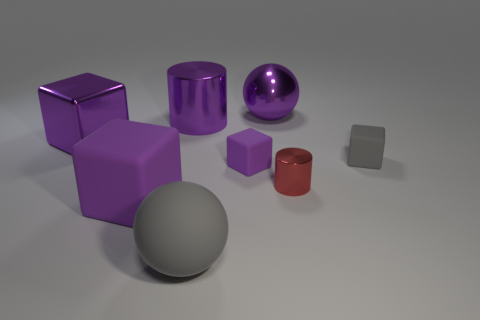Subtract all cyan spheres. How many purple blocks are left? 3 Subtract 1 cubes. How many cubes are left? 3 Add 2 yellow rubber objects. How many objects exist? 10 Subtract all spheres. How many objects are left? 6 Add 3 big cyan spheres. How many big cyan spheres exist? 3 Subtract 1 gray spheres. How many objects are left? 7 Subtract all small purple blocks. Subtract all large metallic cylinders. How many objects are left? 6 Add 5 big gray things. How many big gray things are left? 6 